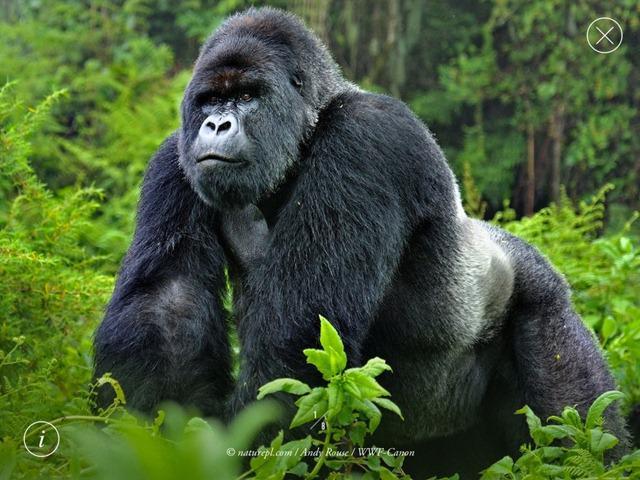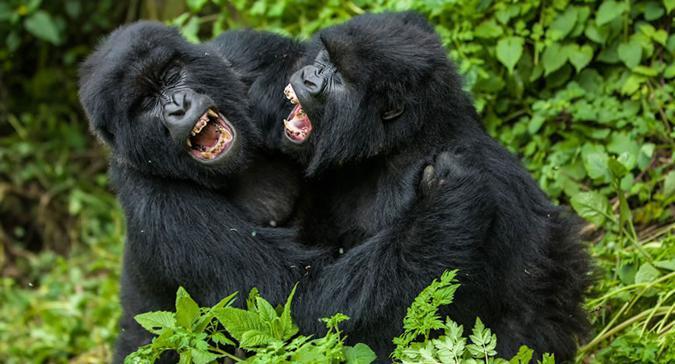The first image is the image on the left, the second image is the image on the right. For the images displayed, is the sentence "A primate is holding a ball in one of the images." factually correct? Answer yes or no. No. The first image is the image on the left, the second image is the image on the right. For the images displayed, is the sentence "A gorilla is holding onto something round and manmade, with a cross-shape on it." factually correct? Answer yes or no. No. 